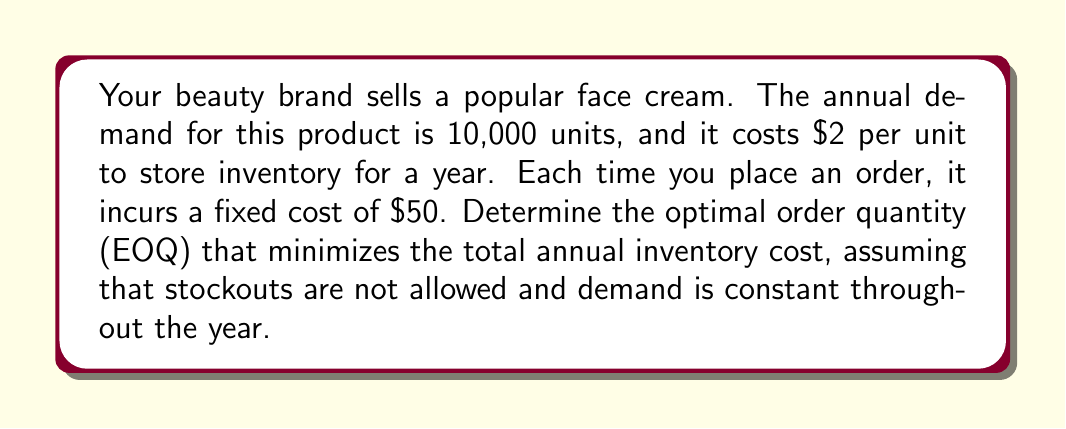Can you answer this question? To solve this problem, we'll use the Economic Order Quantity (EOQ) model, which is ideal for determining optimal inventory levels while balancing storage costs and order costs.

The EOQ formula is:

$$EOQ = \sqrt{\frac{2DS}{H}}$$

Where:
$D$ = Annual demand
$S$ = Fixed cost per order
$H$ = Annual holding cost per unit

Given:
$D = 10,000$ units
$S = \$50$ per order
$H = \$2$ per unit per year

Let's substitute these values into the EOQ formula:

$$EOQ = \sqrt{\frac{2 \cdot 10,000 \cdot 50}{2}}$$

$$EOQ = \sqrt{\frac{1,000,000}{2}}$$

$$EOQ = \sqrt{500,000}$$

$$EOQ = 707.11$$

Since we can't order partial units, we round to the nearest whole number:

$$EOQ = 707 \text{ units}$$

To verify that this minimizes total annual inventory cost, we can calculate the total cost:

Annual ordering cost: $\frac{D}{Q} \cdot S = \frac{10,000}{707} \cdot 50 = \$706.93$

Annual holding cost: $\frac{Q}{2} \cdot H = \frac{707}{2} \cdot 2 = \$707$

Total annual inventory cost: $\$706.93 + \$707 = \$1,413.93$

This is the minimum total annual inventory cost achievable under the given constraints.
Answer: The optimal order quantity (EOQ) is 707 units. 